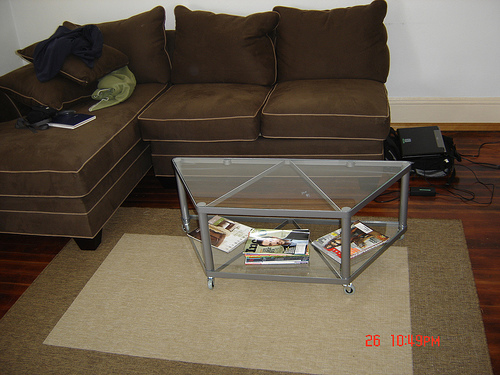<image>
Is the pillow on the glass? No. The pillow is not positioned on the glass. They may be near each other, but the pillow is not supported by or resting on top of the glass. 